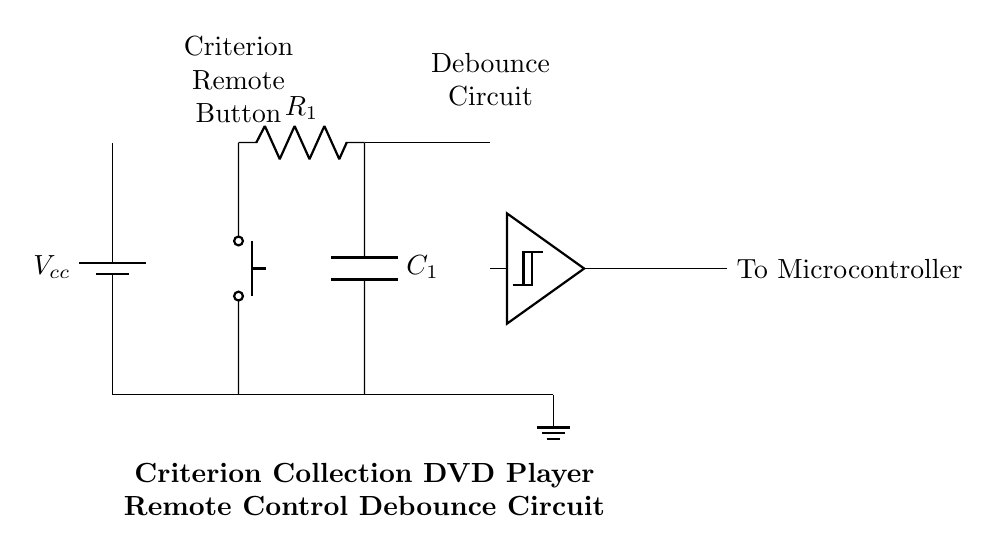What is the type of circuit shown? The circuit is a debounce circuit, which is used to eliminate noise and spurious signals from the pushbutton input. This function is crucial in preventing multiple triggers from a single button press.
Answer: debounce circuit What is the function of the Schmitt Trigger in this circuit? The Schmitt Trigger provides a clean digital output by ensuring that the output state changes only when the input voltage crosses specified thresholds. This process helps stabilize the signal by eliminating noise, which can occur when the pushbutton is pressed or released.
Answer: signal stabilization What are the values of the components in the debounce circuit? The circuit features a resistor labeled R1 and a capacitor labeled C1, whose specific values are not listed in the diagram. However, these components are essential for the debounce timing; they will be determined based on design requirements.
Answer: R1 and C1 What does the pushbutton represent in the circuit? The pushbutton acts as a user input mechanism, allowing the user to trigger the remote control function by pressing it. Its role is key in initiating the debounce process.
Answer: user input What connects the output of the Schmitt Trigger to the microcontroller? The output from the Schmitt Trigger connects directly to the microcontroller with a wire, which transmits the debounced signal for processing. This connection is vital for the system to function correctly.
Answer: wire connection What does Vcc represent in the circuit? Vcc represents the supply voltage that powers the circuit components. It is the source of electrical energy required for the operation of the circuit, including the logic levels for the Schmitt Trigger.
Answer: supply voltage 